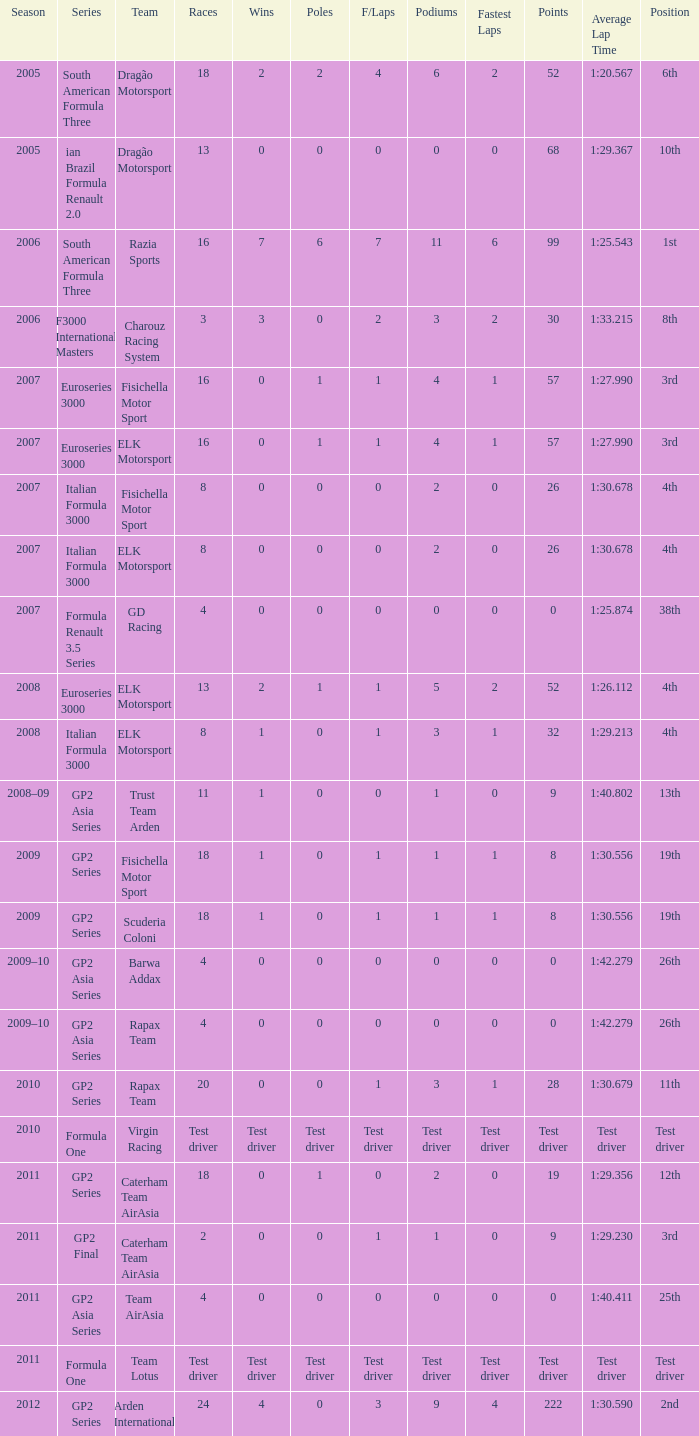What was his position in 2009 with 1 win? 19th, 19th. 